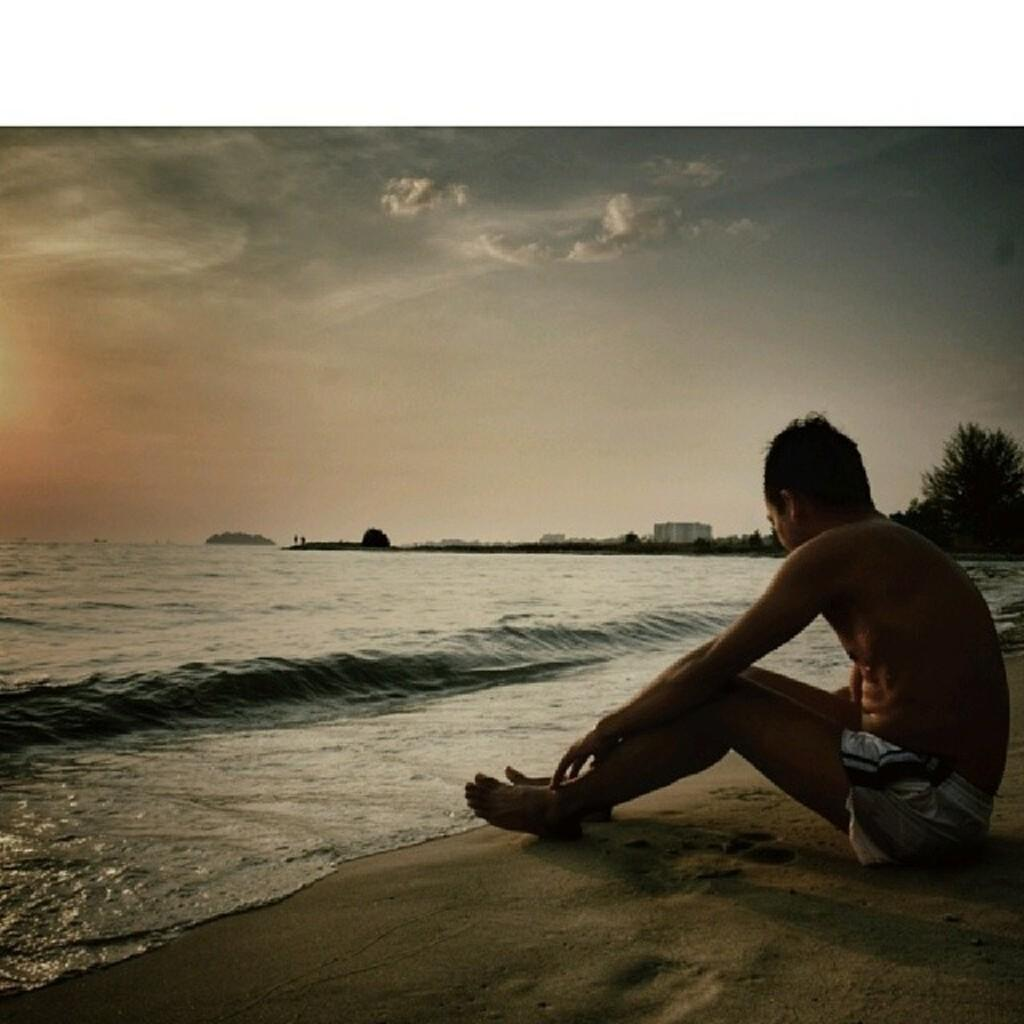What is the person in the image sitting on? The person is sitting on the sand. What is located in front of the person? There is water in front of the person. What can be seen in the background of the image? There are buildings and trees in the background of the image, as well as the sky. What type of leaf can be heard rustling in the image? There is no leaf present in the image, so it cannot be heard rustling. 